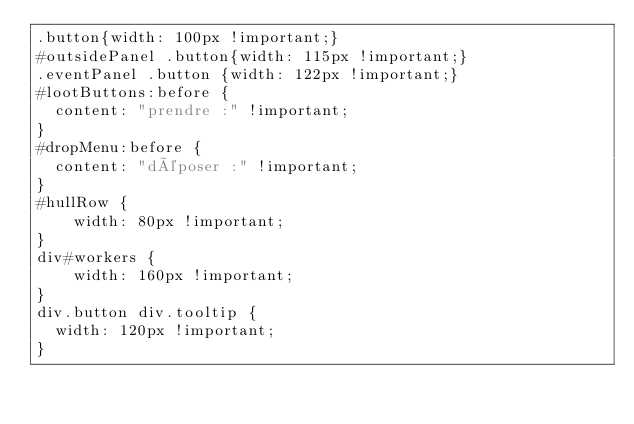Convert code to text. <code><loc_0><loc_0><loc_500><loc_500><_CSS_>.button{width: 100px !important;}
#outsidePanel .button{width: 115px !important;}
.eventPanel .button {width: 122px !important;}
#lootButtons:before {
	content: "prendre :" !important;
}
#dropMenu:before {
	content: "déposer :" !important;
}
#hullRow {
    width: 80px !important;
}
div#workers {
    width: 160px !important;
}
div.button div.tooltip {
	width: 120px !important;
}
</code> 